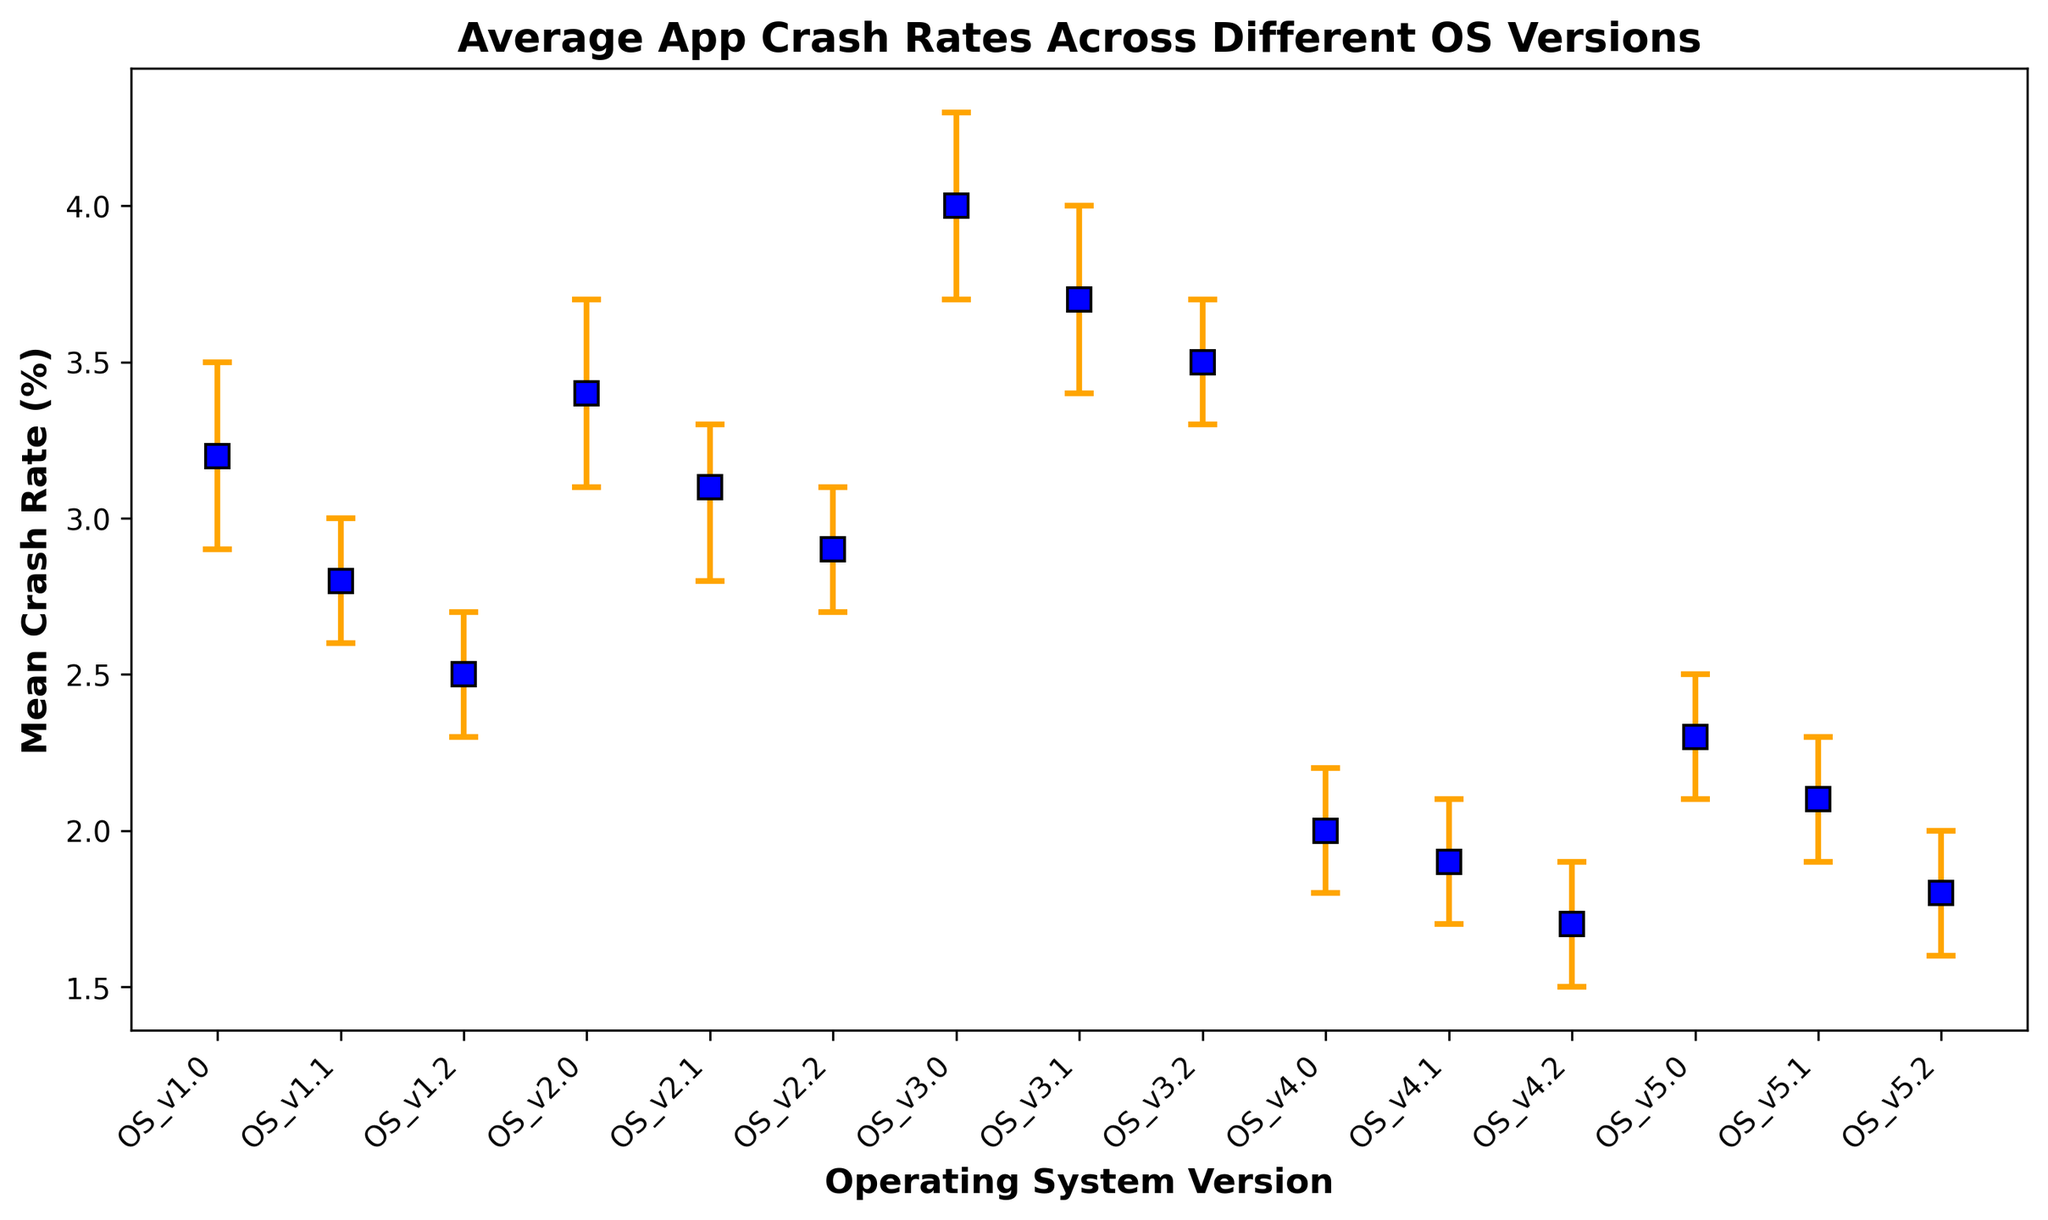Which OS version has the highest mean crash rate? The figure shows mean crash rates for different OS versions. By examining the values, OS_v3.0 has the highest mean crash rate at 4.0%.
Answer: OS_v3.0 Which OS version has the lowest mean crash rate? Checking the figure for the lowest mean crash rate, OS_v4.2 has the lowest mean crash rate at 1.7%.
Answer: OS_v4.2 What is the difference in mean crash rate between OS_v1.0 and OS_v4.1? OS_v1.0 has a mean crash rate of 3.2%, and OS_v4.1 has a mean crash rate of 1.9%. The difference is 3.2% - 1.9% = 1.3%.
Answer: 1.3% Which OS version shows greater variability in crash rates, OS_v2.0 or OS_v5.0? Variability is reflected by the size of the error bars. OS_v2.0 has an error range of (3.7 - 3.1) = 0.6%, and OS_v5.0 has an error range of (2.5 - 2.1) = 0.4%. Thus, OS_v2.0 has greater variability.
Answer: OS_v2.0 Which two consecutive OS versions have the biggest decrease in mean crash rate? By examining the mean crash rates, the biggest decrease between two consecutive versions is from OS_v3.2 (3.5%) to OS_v4.0 (2.0%), a decrease of 3.5% - 2.0% = 1.5%.
Answer: OS_v3.2 to OS_v4.0 What is the mean crash rate range for OS_v3.1? The lower confidence interval is 3.4% and the upper confidence interval is 4.0%. Therefore, the range is [3.4%, 4.0%].
Answer: [3.4%, 4.0%] How does the mean crash rate of OS_v2.2 compare to that of OS_v5.2? The mean crash rate of OS_v2.2 is 2.9% and OS_v5.2 is 1.8%. OS_v2.2 has a higher mean crash rate by 2.9% - 1.8% = 1.1%.
Answer: OS_v2.2 is higher Which OS version's mean crash rate is closest to 2.5%? The mean crash rate of OS_v1.2 is exactly 2.5%, which matches the exact value given.
Answer: OS_v1.2 What is the average mean crash rate for OS versions 4.X? Mean crash rates for OS 4.X are: OS_v4.0 = 2.0%, OS_v4.1 = 1.9%, OS_v4.2 = 1.7%. Average = (2.0 + 1.9 + 1.7)/3 = 1.87%.
Answer: 1.87% 